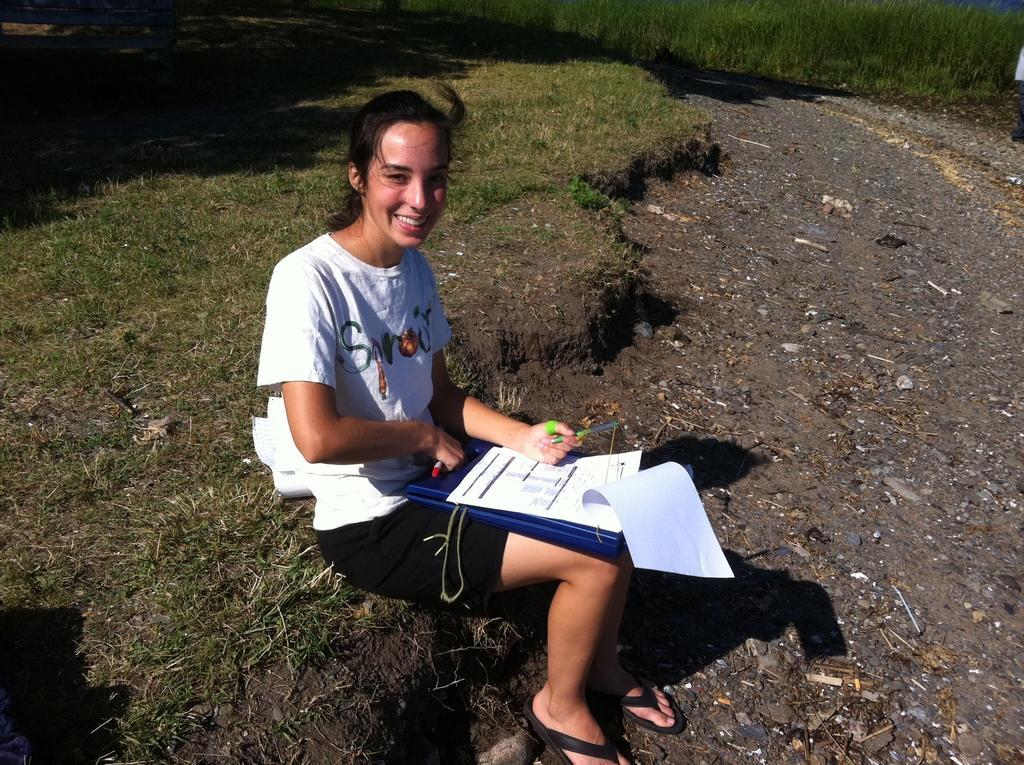How would you summarize this image in a sentence or two? In the picture I can see a woman and she is holding the pens in her hands. She is wearing a white color T-shirt and there is a smile on her face. I can see a blue color file and there are papers on the file. In the background, I can see the green grass. 